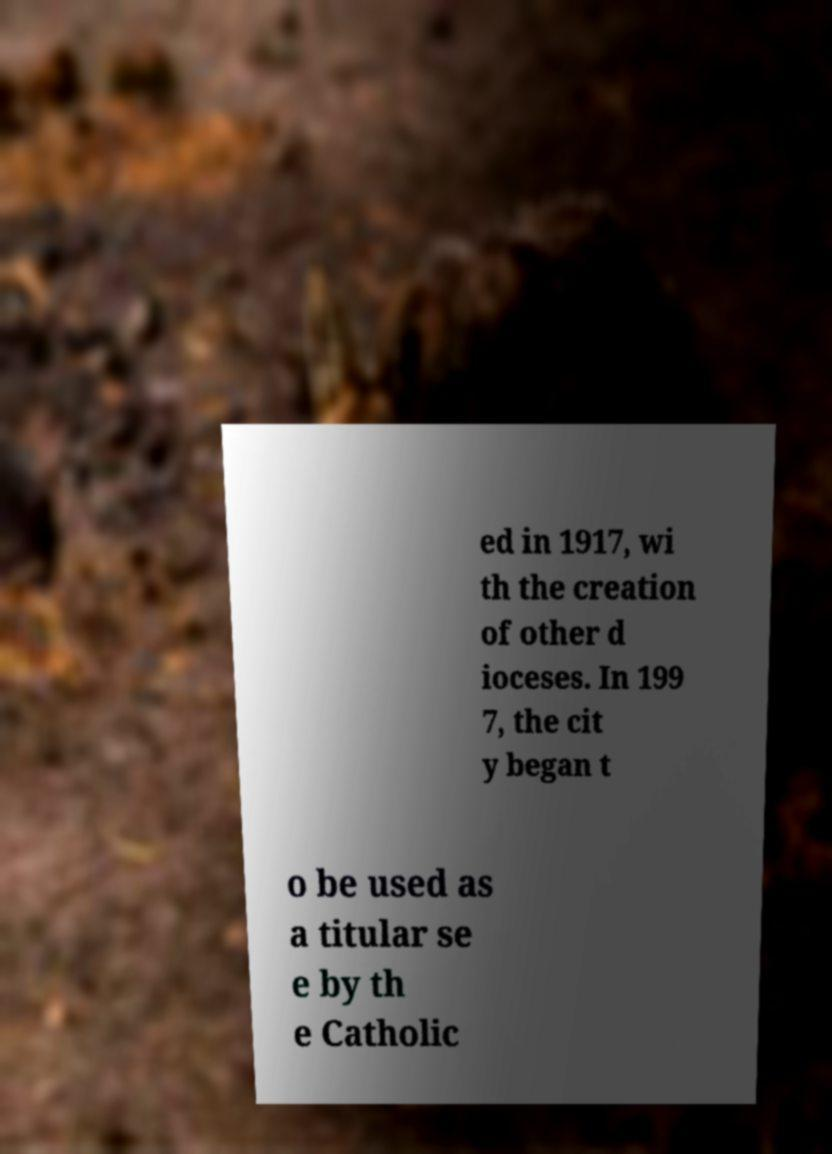Can you read and provide the text displayed in the image?This photo seems to have some interesting text. Can you extract and type it out for me? ed in 1917, wi th the creation of other d ioceses. In 199 7, the cit y began t o be used as a titular se e by th e Catholic 